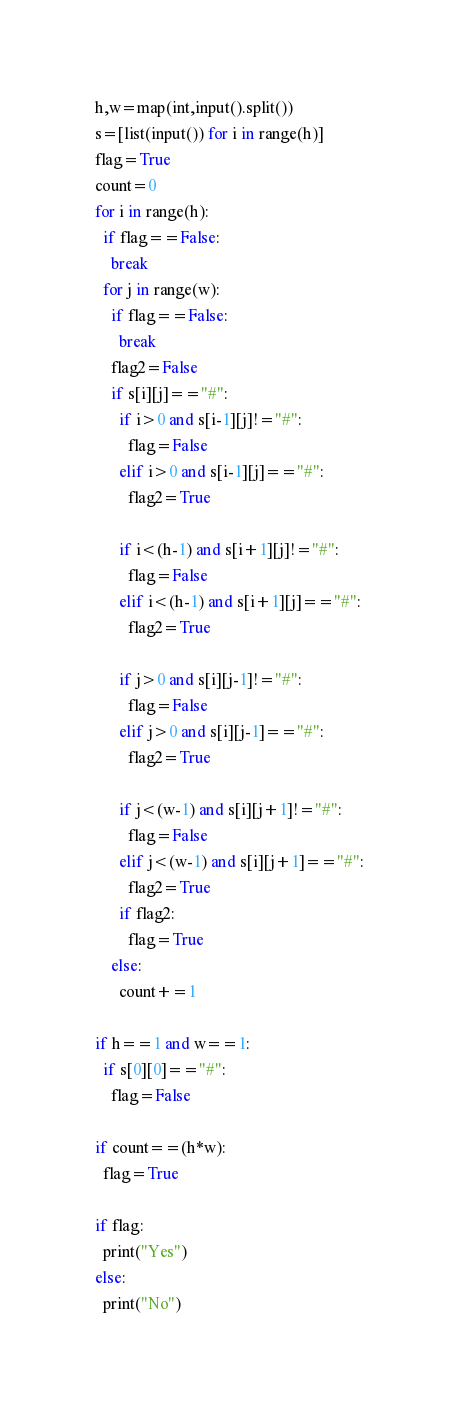Convert code to text. <code><loc_0><loc_0><loc_500><loc_500><_Python_>h,w=map(int,input().split())
s=[list(input()) for i in range(h)]
flag=True
count=0
for i in range(h):
  if flag==False:
    break
  for j in range(w):
    if flag==False:
      break
    flag2=False
    if s[i][j]=="#":
      if i>0 and s[i-1][j]!="#":
        flag=False
      elif i>0 and s[i-1][j]=="#":
        flag2=True
        
      if i<(h-1) and s[i+1][j]!="#":
        flag=False
      elif i<(h-1) and s[i+1][j]=="#":
        flag2=True
        
      if j>0 and s[i][j-1]!="#":
        flag=False
      elif j>0 and s[i][j-1]=="#":
        flag2=True
      
      if j<(w-1) and s[i][j+1]!="#":
        flag=False
      elif j<(w-1) and s[i][j+1]=="#":
        flag2=True
      if flag2:
        flag=True
    else:
      count+=1
        
if h==1 and w==1:
  if s[0][0]=="#":
    flag=False
    
if count==(h*w):
  flag=True
  
if flag:
  print("Yes")
else:
  print("No")</code> 